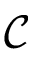<formula> <loc_0><loc_0><loc_500><loc_500>\mathcal { C }</formula> 